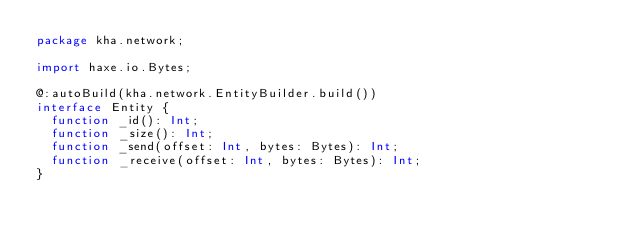Convert code to text. <code><loc_0><loc_0><loc_500><loc_500><_Haxe_>package kha.network;

import haxe.io.Bytes;

@:autoBuild(kha.network.EntityBuilder.build())
interface Entity {
	function _id(): Int;
	function _size(): Int;
	function _send(offset: Int, bytes: Bytes): Int;
	function _receive(offset: Int, bytes: Bytes): Int;
}
</code> 